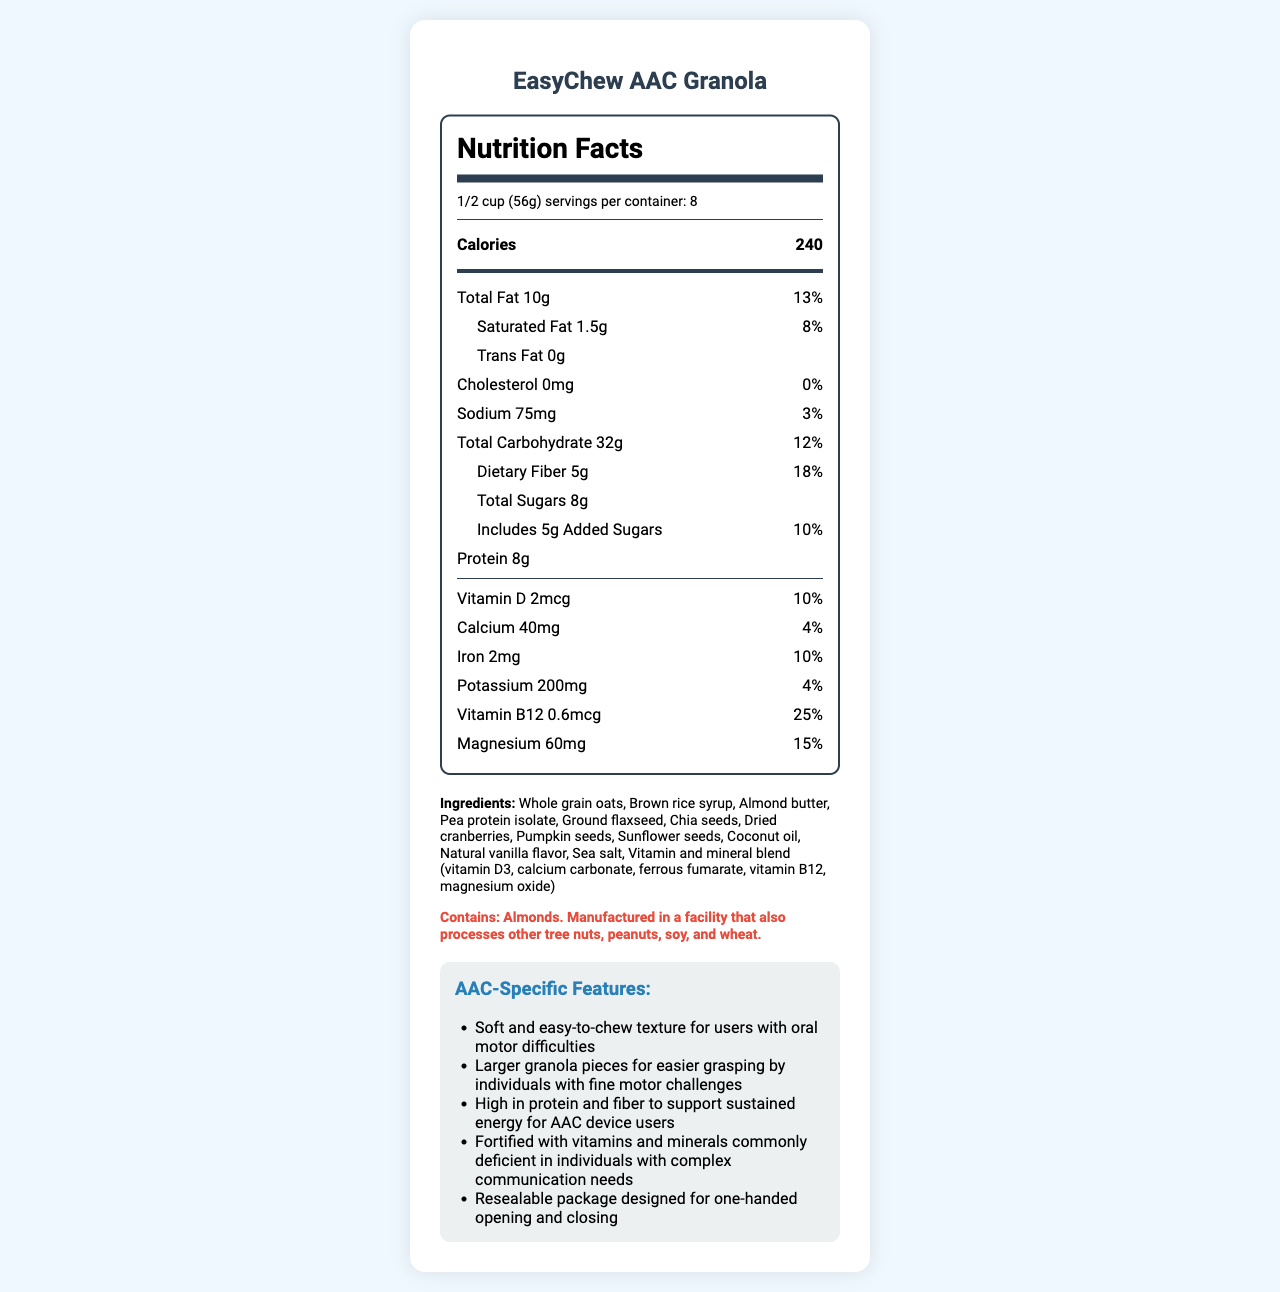what is the serving size? The serving size is listed under the "serving-info" section near the top of the document.
Answer: 1/2 cup (56g) how many calories are there per serving? The calories per serving are listed in the "nutrient-row bold" section at the top of the nutrition facts.
Answer: 240 what is the amount of dietary fiber per serving? The dietary fiber amount is mentioned in the "nutrient-row sub-nutrient" under the total carbohydrate section.
Answer: 5g what vitamins and minerals are included in the granola? These nutrients are listed towards the bottom of the nutrition facts section in individual nutrient rows.
Answer: Vitamin D, Calcium, Iron, Potassium, Vitamin B12, Magnesium how much protein does the granola provide per serving? The protein amount is listed in a nutrient row within the nutrition facts section.
Answer: 8g does the product contain any allergens? The allergen information is provided in the "allergen-info" section, and it states: "Contains: Almonds. Manufactured in a facility that also processes other tree nuts, peanuts, soy, and wheat."
Answer: Yes what unique features make this granola suitable for AAC users? These specific features are listed under the "aac-specific-features" section.
Answer: Soft and easy-to-chew texture, larger granola pieces for easier grasping, high protein and fiber, fortified with vitamins and minerals, resealable package how many servings are there per container? A. 6 B. 8 C. 10 The number of servings per container is provided in the "serving-info" section.
Answer: B. 8 what is the total amount of added sugars in the product? A. 5g B. 8g C. 10g D. 0g The added sugars amount is specified under the "nutrient-row sub-nutrient" of the total carbohydrate section.
Answer: A. 5g which mineral is provided at 25% of the daily value? 1. Calcium 2. Magnesium 3. Potassium 4. Vitamin B12 The daily value percentage for each nutrient is listed in the individual nutrient rows, with Vitamin B12 showing 25%.
Answer: 4. Vitamin B12 is this product suitable for someone with a peanut allergy? The allergen info states it is manufactured in a facility that processes peanuts, indicating potential cross-contamination risk.
Answer: No summarize the document in one sentence. The document includes comprehensive details on nutrition, ingredients, allergens, AAC-specific features, and additional notes from a speech pathologist to ensure suitability for the target demographic.
Answer: The document provides detailed nutrition facts, ingredient information, allergen warnings, and AAC-specific features for the EasyChew AAC Granola, highlighting its suitability for users with fine motor and oral motor challenges. who is the manufacturer of this granola? The manufacturer, NutriCom Wellness, Inc., is not mentioned in the visual information of the provided document.
Answer: Cannot be determined 